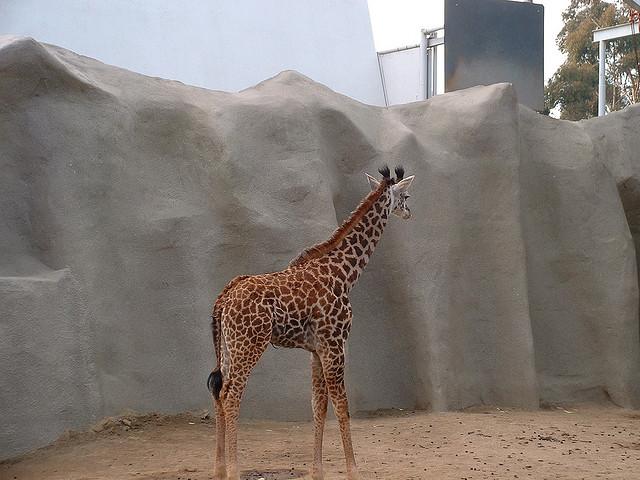What colors are the walls?
Quick response, please. Gray. Is the giraffe trying to lick the wall?
Write a very short answer. No. How tall is this animal?
Keep it brief. 12 ft. 